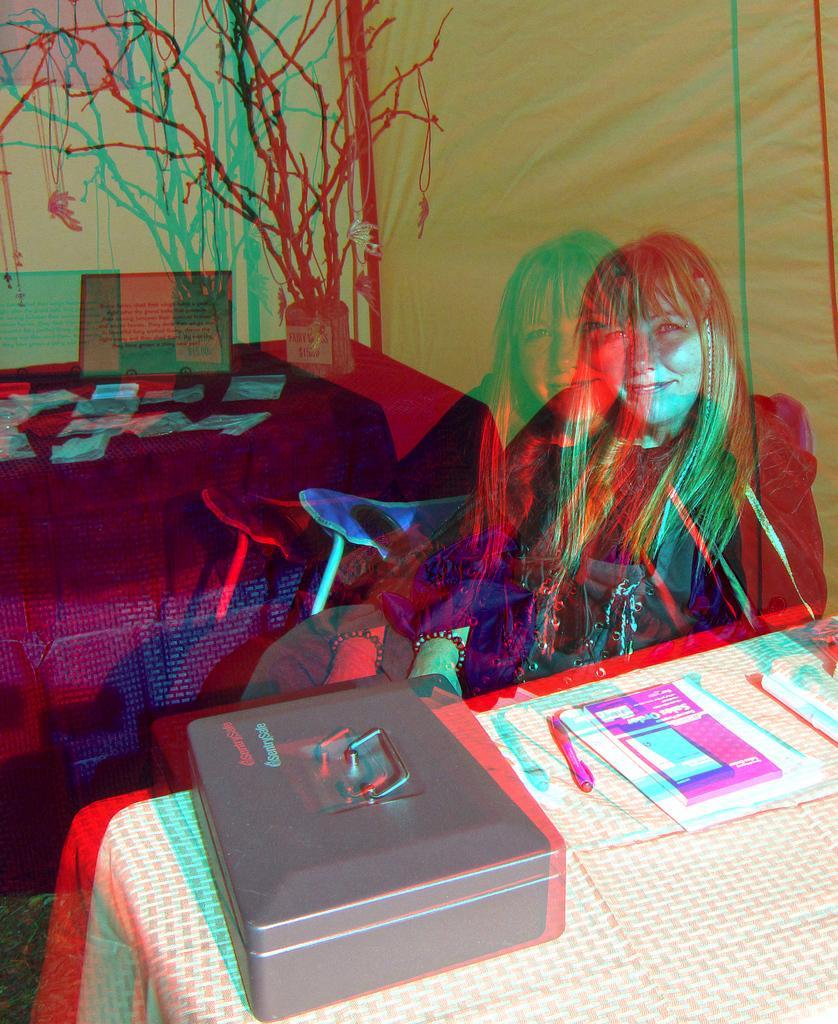How would you summarize this image in a sentence or two? This is an edited image. In this image we can see a lady. There are tables. On the tables there are papers, box and few other items. In the back we can see tree. 